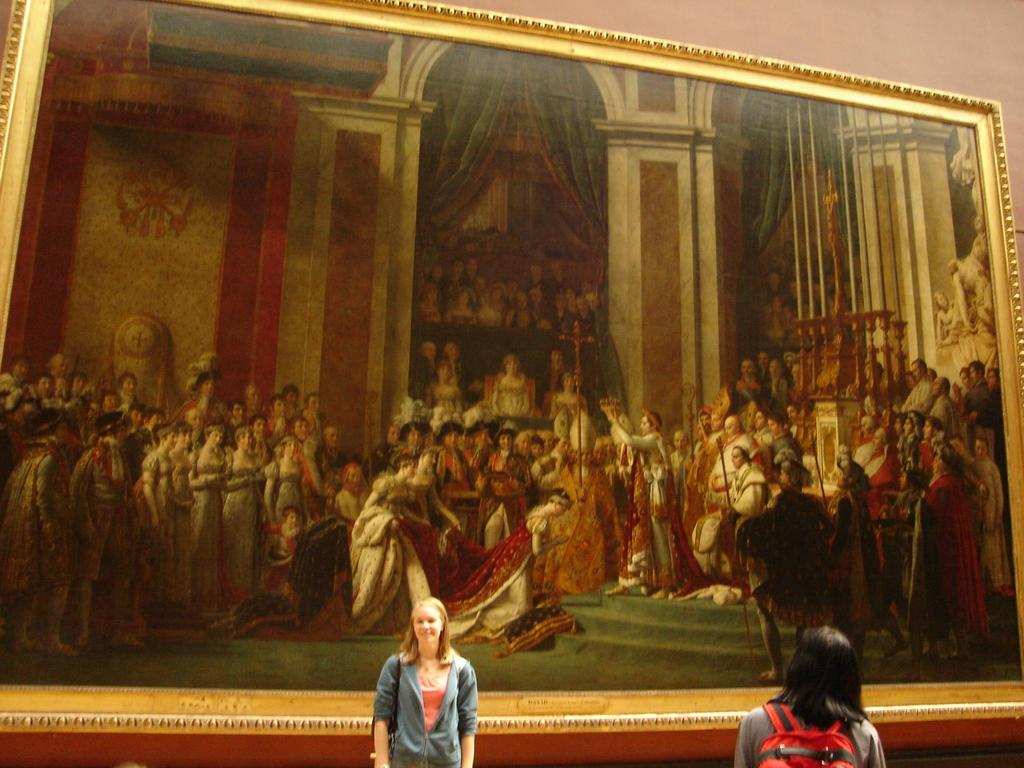How many people are present in the image? There are two girls in the image. What can be seen on the wall in the background? There is a frame on the wall in the background. What is depicted within the frame? The frame contains a depiction of many persons. What type of notebook is being used by the beginner in the image? There is no notebook or beginner present in the image. What kind of flowers are being grown by the girls in the image? There is no mention of flowers or gardening in the image. 